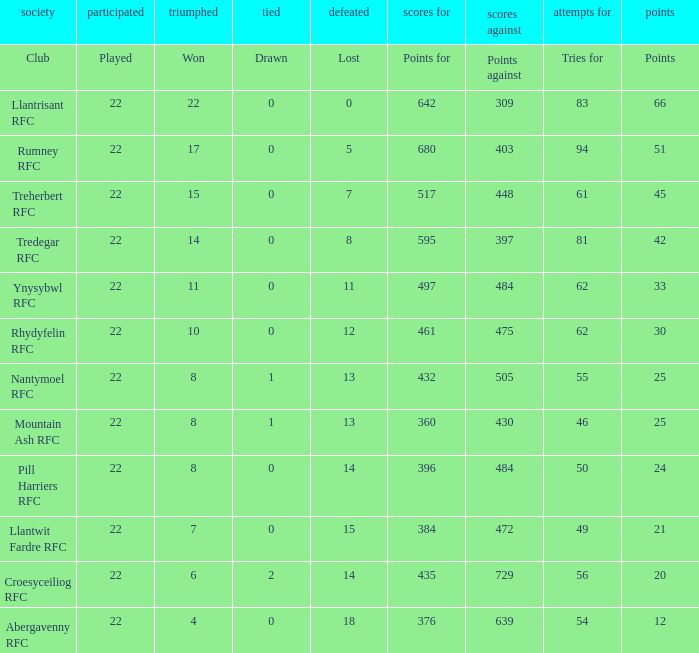Which club lost exactly 7 matches? Treherbert RFC. 